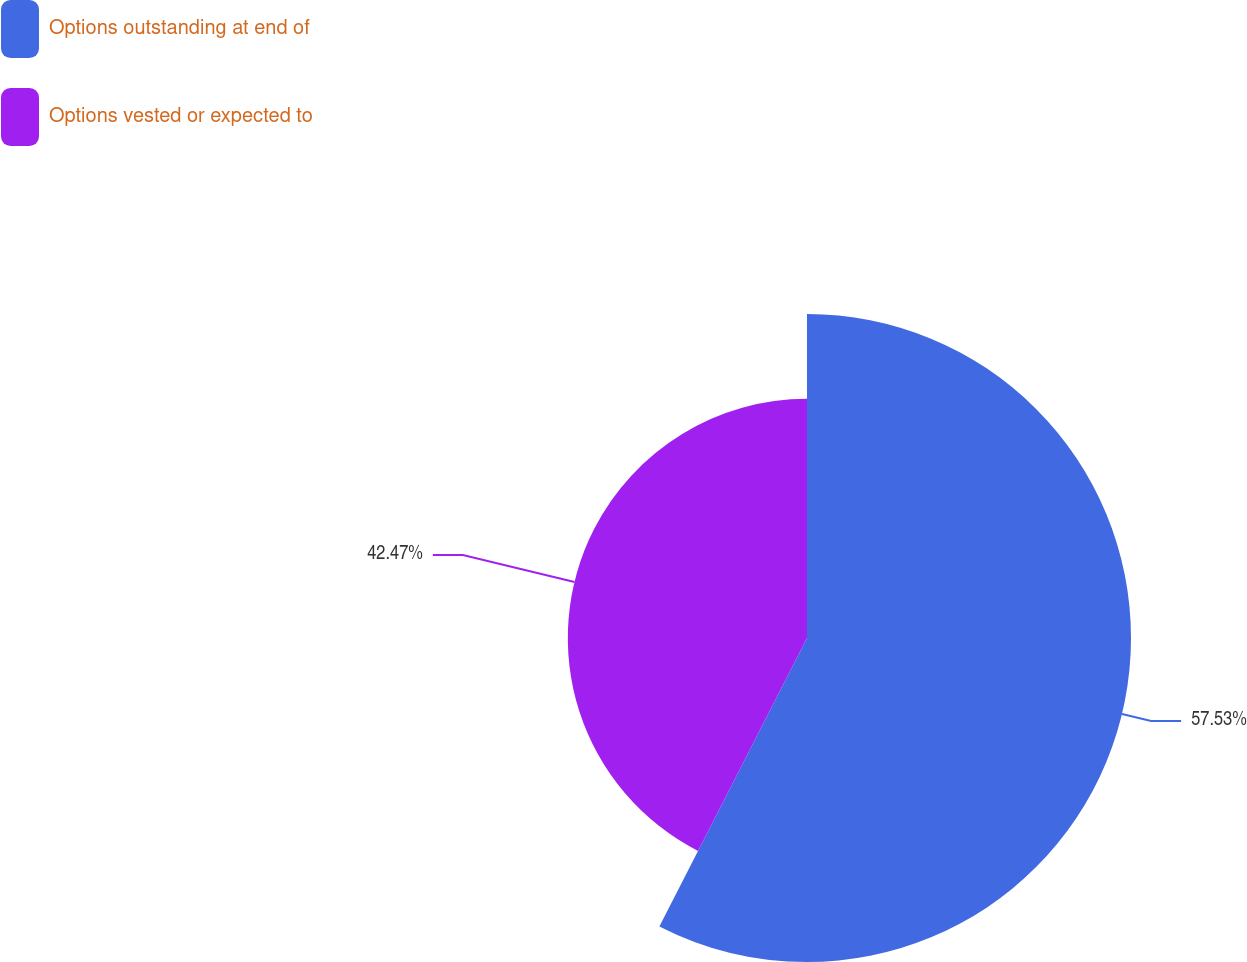Convert chart. <chart><loc_0><loc_0><loc_500><loc_500><pie_chart><fcel>Options outstanding at end of<fcel>Options vested or expected to<nl><fcel>57.53%<fcel>42.47%<nl></chart> 